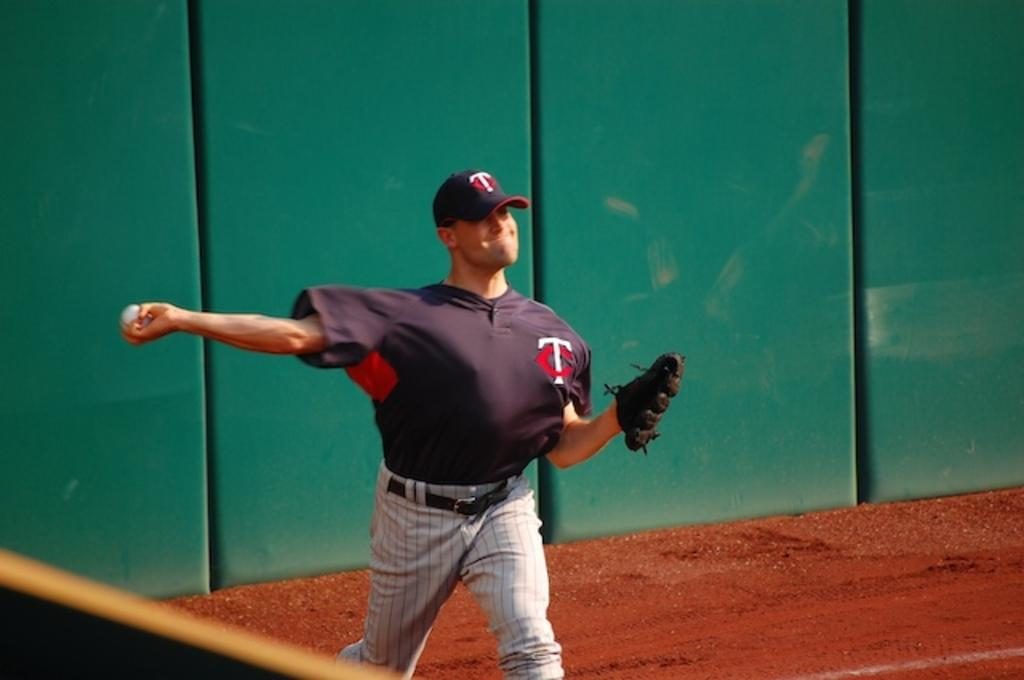Provide a one-sentence caption for the provided image. a baseball player with the letters t and c on his cap and jersey. 